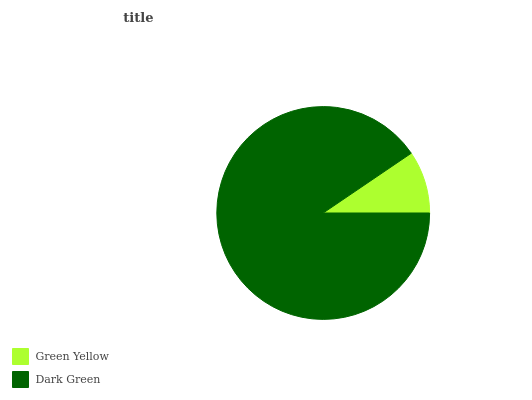Is Green Yellow the minimum?
Answer yes or no. Yes. Is Dark Green the maximum?
Answer yes or no. Yes. Is Dark Green the minimum?
Answer yes or no. No. Is Dark Green greater than Green Yellow?
Answer yes or no. Yes. Is Green Yellow less than Dark Green?
Answer yes or no. Yes. Is Green Yellow greater than Dark Green?
Answer yes or no. No. Is Dark Green less than Green Yellow?
Answer yes or no. No. Is Dark Green the high median?
Answer yes or no. Yes. Is Green Yellow the low median?
Answer yes or no. Yes. Is Green Yellow the high median?
Answer yes or no. No. Is Dark Green the low median?
Answer yes or no. No. 